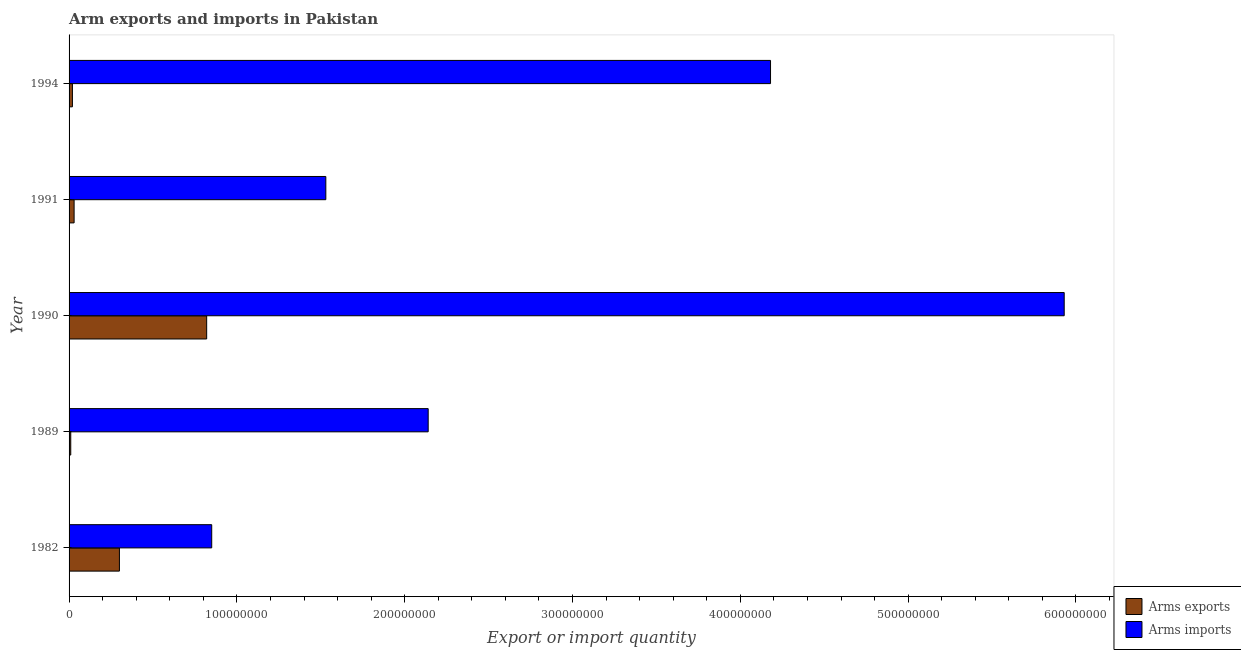Are the number of bars on each tick of the Y-axis equal?
Your answer should be very brief. Yes. How many bars are there on the 4th tick from the top?
Your response must be concise. 2. How many bars are there on the 4th tick from the bottom?
Keep it short and to the point. 2. In how many cases, is the number of bars for a given year not equal to the number of legend labels?
Your answer should be very brief. 0. What is the arms exports in 1991?
Provide a succinct answer. 3.00e+06. Across all years, what is the maximum arms imports?
Make the answer very short. 5.93e+08. Across all years, what is the minimum arms imports?
Offer a terse response. 8.50e+07. In which year was the arms imports maximum?
Your answer should be compact. 1990. What is the total arms exports in the graph?
Make the answer very short. 1.18e+08. What is the difference between the arms exports in 1989 and that in 1994?
Your response must be concise. -1.00e+06. What is the difference between the arms exports in 1989 and the arms imports in 1994?
Make the answer very short. -4.17e+08. What is the average arms exports per year?
Keep it short and to the point. 2.36e+07. In the year 1990, what is the difference between the arms exports and arms imports?
Your answer should be compact. -5.11e+08. What is the ratio of the arms imports in 1982 to that in 1994?
Offer a very short reply. 0.2. Is the arms imports in 1991 less than that in 1994?
Give a very brief answer. Yes. What is the difference between the highest and the second highest arms exports?
Ensure brevity in your answer.  5.20e+07. What is the difference between the highest and the lowest arms imports?
Your response must be concise. 5.08e+08. In how many years, is the arms exports greater than the average arms exports taken over all years?
Keep it short and to the point. 2. Is the sum of the arms exports in 1989 and 1991 greater than the maximum arms imports across all years?
Your answer should be compact. No. What does the 1st bar from the top in 1989 represents?
Your answer should be very brief. Arms imports. What does the 1st bar from the bottom in 1982 represents?
Offer a very short reply. Arms exports. How many bars are there?
Offer a very short reply. 10. What is the difference between two consecutive major ticks on the X-axis?
Give a very brief answer. 1.00e+08. Does the graph contain grids?
Make the answer very short. No. Where does the legend appear in the graph?
Offer a very short reply. Bottom right. How many legend labels are there?
Ensure brevity in your answer.  2. How are the legend labels stacked?
Give a very brief answer. Vertical. What is the title of the graph?
Provide a short and direct response. Arm exports and imports in Pakistan. Does "Urban" appear as one of the legend labels in the graph?
Provide a succinct answer. No. What is the label or title of the X-axis?
Your answer should be very brief. Export or import quantity. What is the label or title of the Y-axis?
Provide a succinct answer. Year. What is the Export or import quantity of Arms exports in 1982?
Offer a very short reply. 3.00e+07. What is the Export or import quantity of Arms imports in 1982?
Provide a short and direct response. 8.50e+07. What is the Export or import quantity in Arms imports in 1989?
Give a very brief answer. 2.14e+08. What is the Export or import quantity in Arms exports in 1990?
Keep it short and to the point. 8.20e+07. What is the Export or import quantity in Arms imports in 1990?
Your response must be concise. 5.93e+08. What is the Export or import quantity of Arms imports in 1991?
Your answer should be very brief. 1.53e+08. What is the Export or import quantity in Arms exports in 1994?
Ensure brevity in your answer.  2.00e+06. What is the Export or import quantity in Arms imports in 1994?
Your answer should be compact. 4.18e+08. Across all years, what is the maximum Export or import quantity of Arms exports?
Make the answer very short. 8.20e+07. Across all years, what is the maximum Export or import quantity in Arms imports?
Keep it short and to the point. 5.93e+08. Across all years, what is the minimum Export or import quantity in Arms exports?
Offer a very short reply. 1.00e+06. Across all years, what is the minimum Export or import quantity of Arms imports?
Provide a succinct answer. 8.50e+07. What is the total Export or import quantity of Arms exports in the graph?
Ensure brevity in your answer.  1.18e+08. What is the total Export or import quantity in Arms imports in the graph?
Provide a short and direct response. 1.46e+09. What is the difference between the Export or import quantity in Arms exports in 1982 and that in 1989?
Keep it short and to the point. 2.90e+07. What is the difference between the Export or import quantity in Arms imports in 1982 and that in 1989?
Keep it short and to the point. -1.29e+08. What is the difference between the Export or import quantity in Arms exports in 1982 and that in 1990?
Ensure brevity in your answer.  -5.20e+07. What is the difference between the Export or import quantity of Arms imports in 1982 and that in 1990?
Offer a terse response. -5.08e+08. What is the difference between the Export or import quantity in Arms exports in 1982 and that in 1991?
Provide a short and direct response. 2.70e+07. What is the difference between the Export or import quantity of Arms imports in 1982 and that in 1991?
Offer a terse response. -6.80e+07. What is the difference between the Export or import quantity of Arms exports in 1982 and that in 1994?
Your answer should be compact. 2.80e+07. What is the difference between the Export or import quantity in Arms imports in 1982 and that in 1994?
Offer a terse response. -3.33e+08. What is the difference between the Export or import quantity of Arms exports in 1989 and that in 1990?
Give a very brief answer. -8.10e+07. What is the difference between the Export or import quantity of Arms imports in 1989 and that in 1990?
Ensure brevity in your answer.  -3.79e+08. What is the difference between the Export or import quantity of Arms exports in 1989 and that in 1991?
Give a very brief answer. -2.00e+06. What is the difference between the Export or import quantity in Arms imports in 1989 and that in 1991?
Provide a short and direct response. 6.10e+07. What is the difference between the Export or import quantity of Arms imports in 1989 and that in 1994?
Your answer should be compact. -2.04e+08. What is the difference between the Export or import quantity in Arms exports in 1990 and that in 1991?
Offer a very short reply. 7.90e+07. What is the difference between the Export or import quantity of Arms imports in 1990 and that in 1991?
Give a very brief answer. 4.40e+08. What is the difference between the Export or import quantity of Arms exports in 1990 and that in 1994?
Provide a short and direct response. 8.00e+07. What is the difference between the Export or import quantity in Arms imports in 1990 and that in 1994?
Your answer should be compact. 1.75e+08. What is the difference between the Export or import quantity in Arms imports in 1991 and that in 1994?
Keep it short and to the point. -2.65e+08. What is the difference between the Export or import quantity in Arms exports in 1982 and the Export or import quantity in Arms imports in 1989?
Make the answer very short. -1.84e+08. What is the difference between the Export or import quantity of Arms exports in 1982 and the Export or import quantity of Arms imports in 1990?
Provide a succinct answer. -5.63e+08. What is the difference between the Export or import quantity of Arms exports in 1982 and the Export or import quantity of Arms imports in 1991?
Your answer should be compact. -1.23e+08. What is the difference between the Export or import quantity in Arms exports in 1982 and the Export or import quantity in Arms imports in 1994?
Offer a terse response. -3.88e+08. What is the difference between the Export or import quantity in Arms exports in 1989 and the Export or import quantity in Arms imports in 1990?
Your answer should be compact. -5.92e+08. What is the difference between the Export or import quantity in Arms exports in 1989 and the Export or import quantity in Arms imports in 1991?
Offer a terse response. -1.52e+08. What is the difference between the Export or import quantity of Arms exports in 1989 and the Export or import quantity of Arms imports in 1994?
Provide a short and direct response. -4.17e+08. What is the difference between the Export or import quantity in Arms exports in 1990 and the Export or import quantity in Arms imports in 1991?
Give a very brief answer. -7.10e+07. What is the difference between the Export or import quantity in Arms exports in 1990 and the Export or import quantity in Arms imports in 1994?
Provide a short and direct response. -3.36e+08. What is the difference between the Export or import quantity of Arms exports in 1991 and the Export or import quantity of Arms imports in 1994?
Make the answer very short. -4.15e+08. What is the average Export or import quantity of Arms exports per year?
Provide a short and direct response. 2.36e+07. What is the average Export or import quantity in Arms imports per year?
Provide a succinct answer. 2.93e+08. In the year 1982, what is the difference between the Export or import quantity of Arms exports and Export or import quantity of Arms imports?
Give a very brief answer. -5.50e+07. In the year 1989, what is the difference between the Export or import quantity in Arms exports and Export or import quantity in Arms imports?
Make the answer very short. -2.13e+08. In the year 1990, what is the difference between the Export or import quantity of Arms exports and Export or import quantity of Arms imports?
Give a very brief answer. -5.11e+08. In the year 1991, what is the difference between the Export or import quantity in Arms exports and Export or import quantity in Arms imports?
Your answer should be very brief. -1.50e+08. In the year 1994, what is the difference between the Export or import quantity in Arms exports and Export or import quantity in Arms imports?
Your answer should be compact. -4.16e+08. What is the ratio of the Export or import quantity in Arms imports in 1982 to that in 1989?
Offer a very short reply. 0.4. What is the ratio of the Export or import quantity of Arms exports in 1982 to that in 1990?
Provide a succinct answer. 0.37. What is the ratio of the Export or import quantity in Arms imports in 1982 to that in 1990?
Give a very brief answer. 0.14. What is the ratio of the Export or import quantity in Arms exports in 1982 to that in 1991?
Provide a succinct answer. 10. What is the ratio of the Export or import quantity in Arms imports in 1982 to that in 1991?
Give a very brief answer. 0.56. What is the ratio of the Export or import quantity in Arms exports in 1982 to that in 1994?
Give a very brief answer. 15. What is the ratio of the Export or import quantity of Arms imports in 1982 to that in 1994?
Keep it short and to the point. 0.2. What is the ratio of the Export or import quantity in Arms exports in 1989 to that in 1990?
Your answer should be very brief. 0.01. What is the ratio of the Export or import quantity in Arms imports in 1989 to that in 1990?
Offer a terse response. 0.36. What is the ratio of the Export or import quantity of Arms exports in 1989 to that in 1991?
Your answer should be compact. 0.33. What is the ratio of the Export or import quantity in Arms imports in 1989 to that in 1991?
Ensure brevity in your answer.  1.4. What is the ratio of the Export or import quantity of Arms imports in 1989 to that in 1994?
Your answer should be very brief. 0.51. What is the ratio of the Export or import quantity of Arms exports in 1990 to that in 1991?
Give a very brief answer. 27.33. What is the ratio of the Export or import quantity in Arms imports in 1990 to that in 1991?
Make the answer very short. 3.88. What is the ratio of the Export or import quantity in Arms imports in 1990 to that in 1994?
Your answer should be very brief. 1.42. What is the ratio of the Export or import quantity of Arms exports in 1991 to that in 1994?
Offer a terse response. 1.5. What is the ratio of the Export or import quantity of Arms imports in 1991 to that in 1994?
Give a very brief answer. 0.37. What is the difference between the highest and the second highest Export or import quantity of Arms exports?
Give a very brief answer. 5.20e+07. What is the difference between the highest and the second highest Export or import quantity in Arms imports?
Keep it short and to the point. 1.75e+08. What is the difference between the highest and the lowest Export or import quantity of Arms exports?
Keep it short and to the point. 8.10e+07. What is the difference between the highest and the lowest Export or import quantity of Arms imports?
Give a very brief answer. 5.08e+08. 